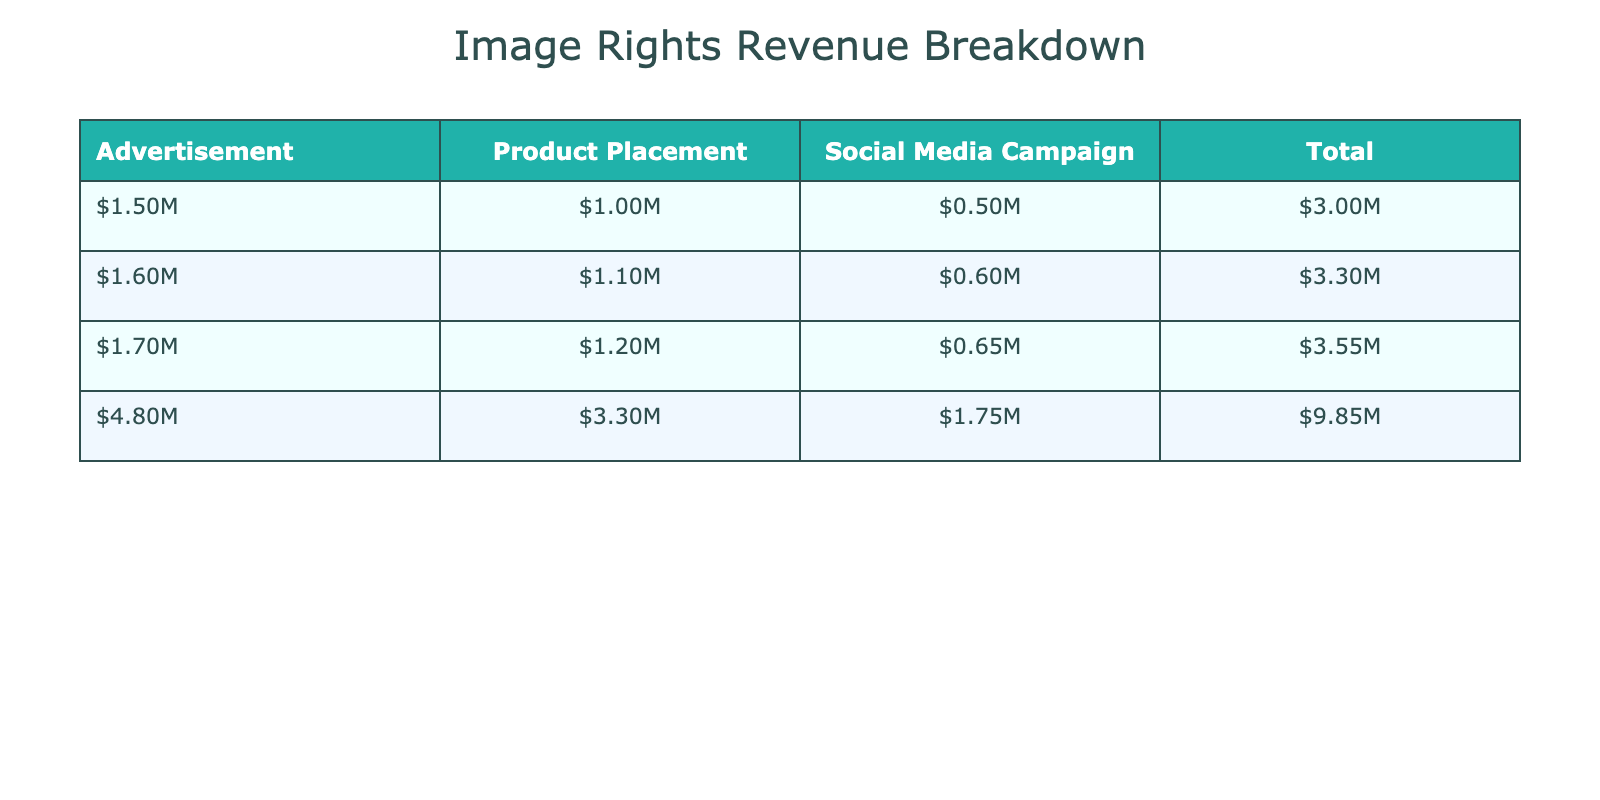What was the total revenue from advertisements in 2021? The total revenue from advertisements in 2021 can be found directly in the table under the Advertisement column for 2021, which shows $1,500,000.
Answer: $1,500,000 Which project type generated the highest revenue in 2022? To find out which project type generated the highest revenue in 2022, we look at all project types for that year. Advertisement shows $1,600,000, Product Placement shows $1,100,000, and Social Media Campaign shows $600,000. The highest revenue among these is from Advertisement.
Answer: Advertisement What is the difference in revenue from social media campaigns between 2021 and 2023? For 2021, the revenue from social media campaigns is $500,000, and for 2023, it is $650,000. To find the difference, we subtract $500,000 from $650,000, yielding a difference of $150,000.
Answer: $150,000 Did the total revenue from product placements increase every year? To determine if total revenue from product placements increased every year, we can check the totals: 2021 is $1,000,000, 2022 is $1,100,000, and 2023 is $1,200,000. Since each year shows an increase, the answer is yes.
Answer: Yes What is the total revenue generated from all project types in 2023? The total revenue in 2023 can be calculated by adding all the project types: Advertisement ($1,700,000) + Product Placement ($1,200,000) + Social Media Campaign ($650,000) = $3,550,000.
Answer: $3,550,000 What percentage of total revenue in 2021 came from advertisements? In 2021, the total revenue across all project types is $1,500,000 (Advertisement) + $1,000,000 (Product Placement) + $500,000 (Social Media Campaign) = $3,000,000. The percentage from advertisements is calculated as ($1,500,000 / $3,000,000) * 100 = 50%.
Answer: 50% Which brand was associated with the highest revenue from product placements in 2022? In 2022, the Product Placement shows that Adidias generated $1,100,000, which is the only entry for that project type that year. Thus, the highest revenue is associated with Adidas.
Answer: Adidas What was the total revenue from all projects across all years? To find the total revenue from all projects, sum the total revenues for all three years: 2021 total ($3,000,000) + 2022 total ($2,800,000) + 2023 total ($3,550,000) = $9,350,000.
Answer: $9,350,000 